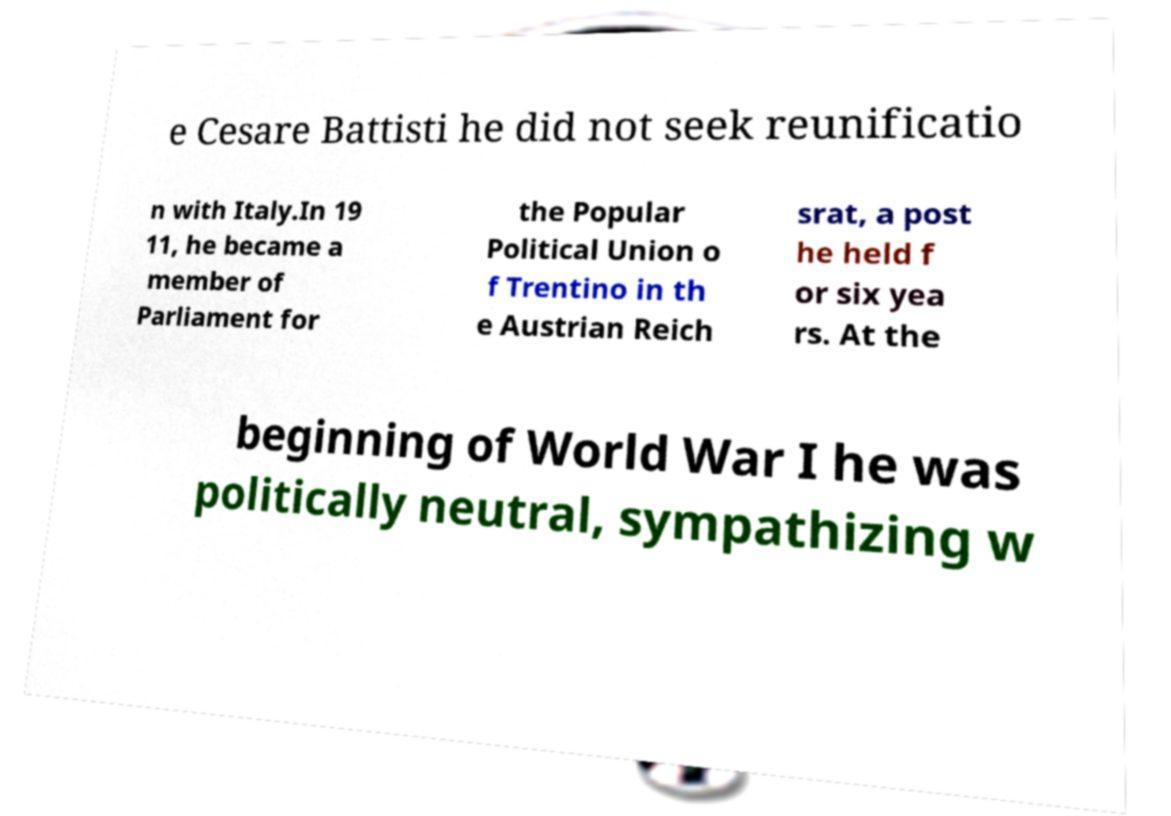Can you accurately transcribe the text from the provided image for me? e Cesare Battisti he did not seek reunificatio n with Italy.In 19 11, he became a member of Parliament for the Popular Political Union o f Trentino in th e Austrian Reich srat, a post he held f or six yea rs. At the beginning of World War I he was politically neutral, sympathizing w 